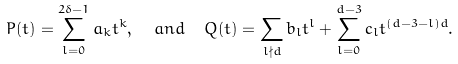Convert formula to latex. <formula><loc_0><loc_0><loc_500><loc_500>P ( t ) = \sum _ { l = 0 } ^ { 2 \delta - 1 } a _ { k } t ^ { k } , \ \ a n d \ \ Q ( t ) = \sum _ { l \nmid d } b _ { l } t ^ { l } + \sum _ { l = 0 } ^ { d - 3 } c _ { l } t ^ { ( d - 3 - l ) d } .</formula> 